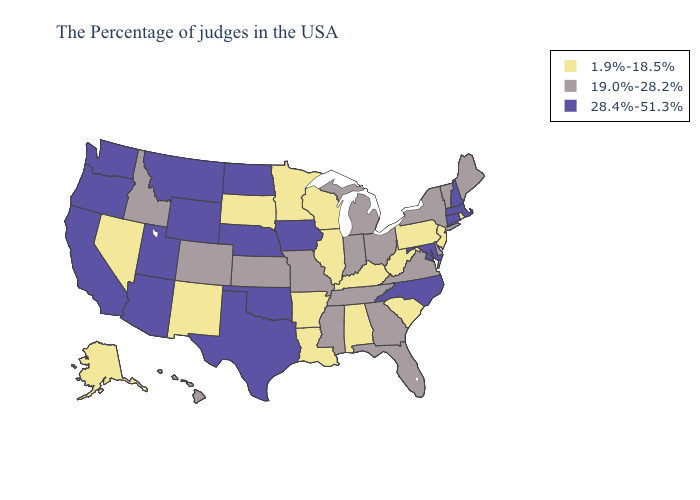What is the lowest value in the West?
Write a very short answer. 1.9%-18.5%. What is the highest value in the USA?
Be succinct. 28.4%-51.3%. Name the states that have a value in the range 28.4%-51.3%?
Concise answer only. Massachusetts, New Hampshire, Connecticut, Maryland, North Carolina, Iowa, Nebraska, Oklahoma, Texas, North Dakota, Wyoming, Utah, Montana, Arizona, California, Washington, Oregon. Name the states that have a value in the range 1.9%-18.5%?
Be succinct. Rhode Island, New Jersey, Pennsylvania, South Carolina, West Virginia, Kentucky, Alabama, Wisconsin, Illinois, Louisiana, Arkansas, Minnesota, South Dakota, New Mexico, Nevada, Alaska. What is the highest value in states that border Wyoming?
Give a very brief answer. 28.4%-51.3%. Does Michigan have the highest value in the USA?
Answer briefly. No. Name the states that have a value in the range 1.9%-18.5%?
Give a very brief answer. Rhode Island, New Jersey, Pennsylvania, South Carolina, West Virginia, Kentucky, Alabama, Wisconsin, Illinois, Louisiana, Arkansas, Minnesota, South Dakota, New Mexico, Nevada, Alaska. What is the value of Alaska?
Write a very short answer. 1.9%-18.5%. Which states have the highest value in the USA?
Write a very short answer. Massachusetts, New Hampshire, Connecticut, Maryland, North Carolina, Iowa, Nebraska, Oklahoma, Texas, North Dakota, Wyoming, Utah, Montana, Arizona, California, Washington, Oregon. What is the lowest value in the USA?
Answer briefly. 1.9%-18.5%. Does Iowa have the highest value in the MidWest?
Give a very brief answer. Yes. What is the highest value in states that border Montana?
Short answer required. 28.4%-51.3%. How many symbols are there in the legend?
Concise answer only. 3. Does New Hampshire have the highest value in the Northeast?
Concise answer only. Yes. What is the value of Massachusetts?
Be succinct. 28.4%-51.3%. 